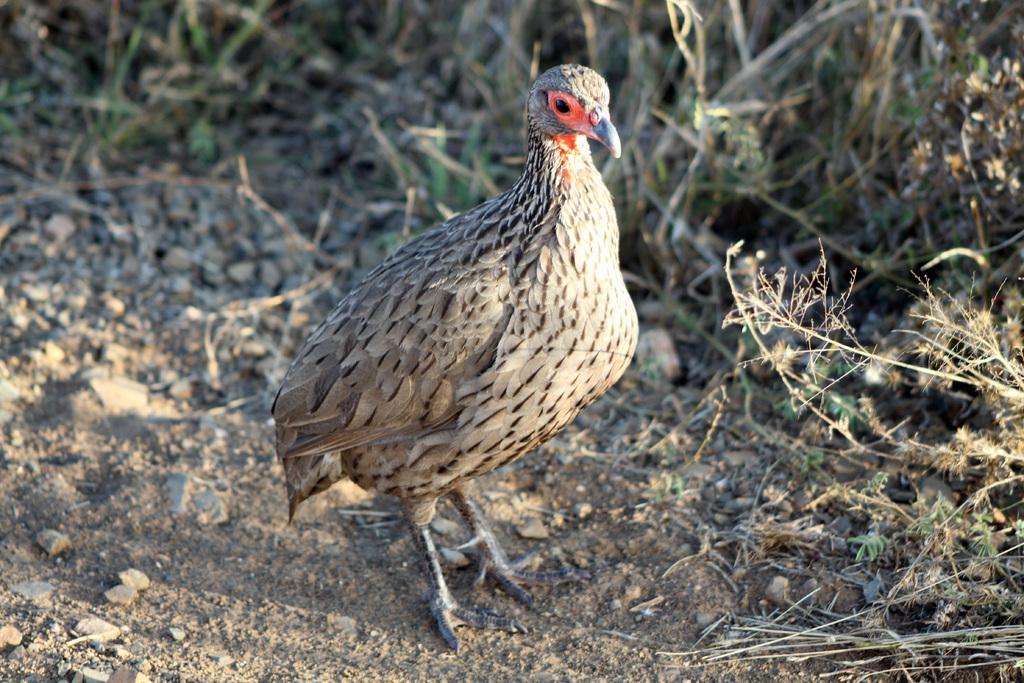Could you give a brief overview of what you see in this image? This image is taken outdoors. At the bottom of the image there is a ground with grass and pebbles on it. In the background there are a few plants. In the middle of the image there is a bird on the ground. 